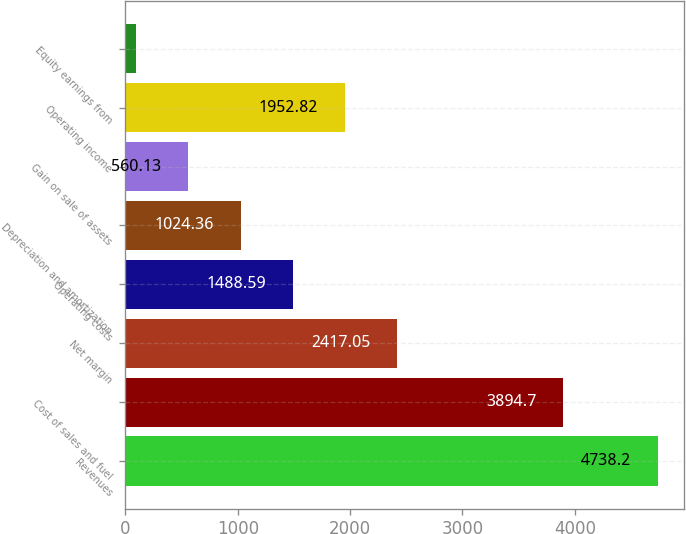<chart> <loc_0><loc_0><loc_500><loc_500><bar_chart><fcel>Revenues<fcel>Cost of sales and fuel<fcel>Net margin<fcel>Operating costs<fcel>Depreciation and amortization<fcel>Gain on sale of assets<fcel>Operating income<fcel>Equity earnings from<nl><fcel>4738.2<fcel>3894.7<fcel>2417.05<fcel>1488.59<fcel>1024.36<fcel>560.13<fcel>1952.82<fcel>95.9<nl></chart> 